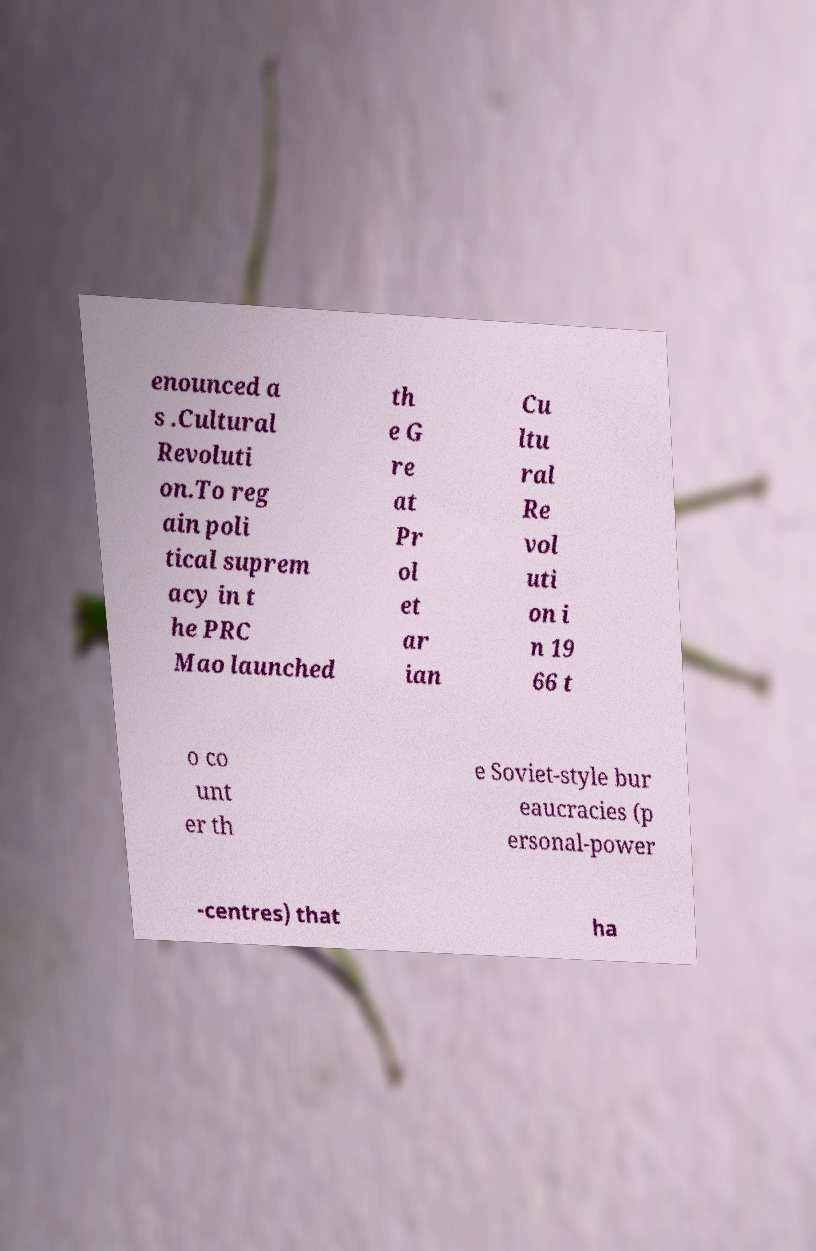Could you assist in decoding the text presented in this image and type it out clearly? enounced a s .Cultural Revoluti on.To reg ain poli tical suprem acy in t he PRC Mao launched th e G re at Pr ol et ar ian Cu ltu ral Re vol uti on i n 19 66 t o co unt er th e Soviet-style bur eaucracies (p ersonal-power -centres) that ha 